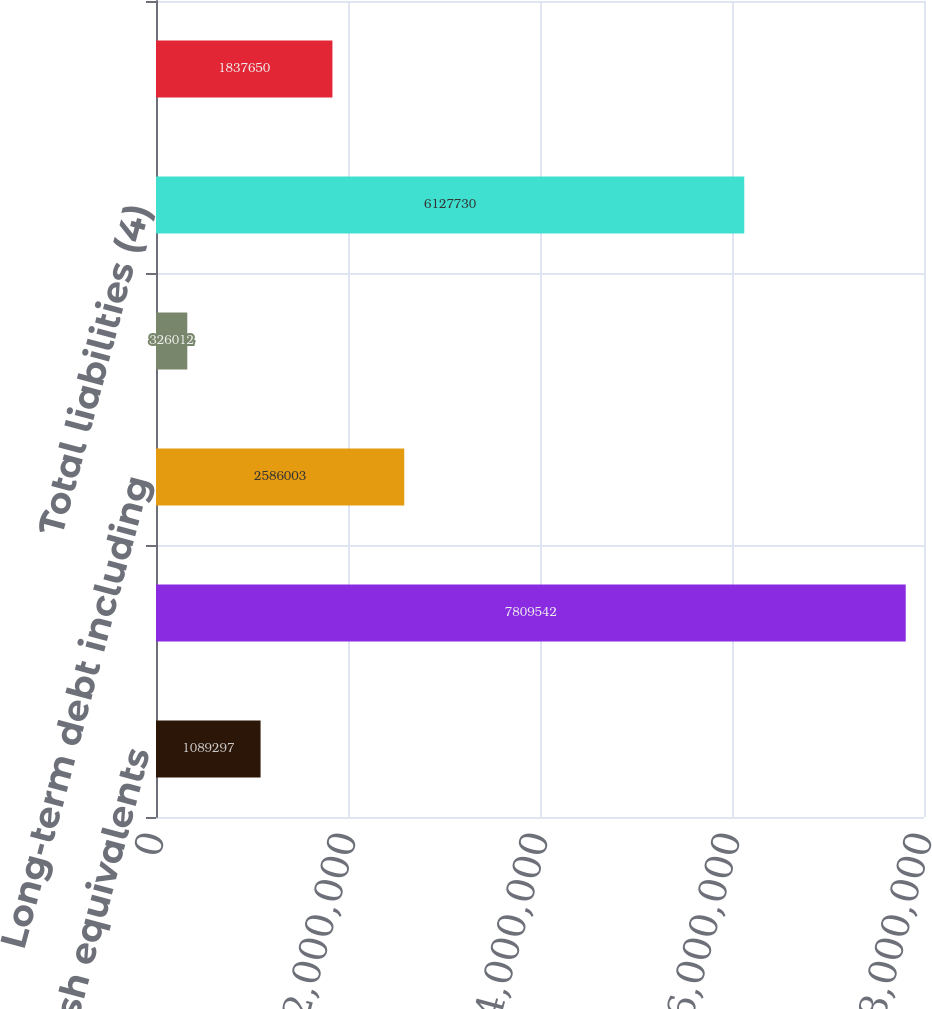<chart> <loc_0><loc_0><loc_500><loc_500><bar_chart><fcel>Cash and cash equivalents<fcel>Total assets (4)<fcel>Long-term debt including<fcel>Notes payable on real estate<fcel>Total liabilities (4)<fcel>Total CBRE Group Inc<nl><fcel>1.0893e+06<fcel>7.80954e+06<fcel>2.586e+06<fcel>326012<fcel>6.12773e+06<fcel>1.83765e+06<nl></chart> 